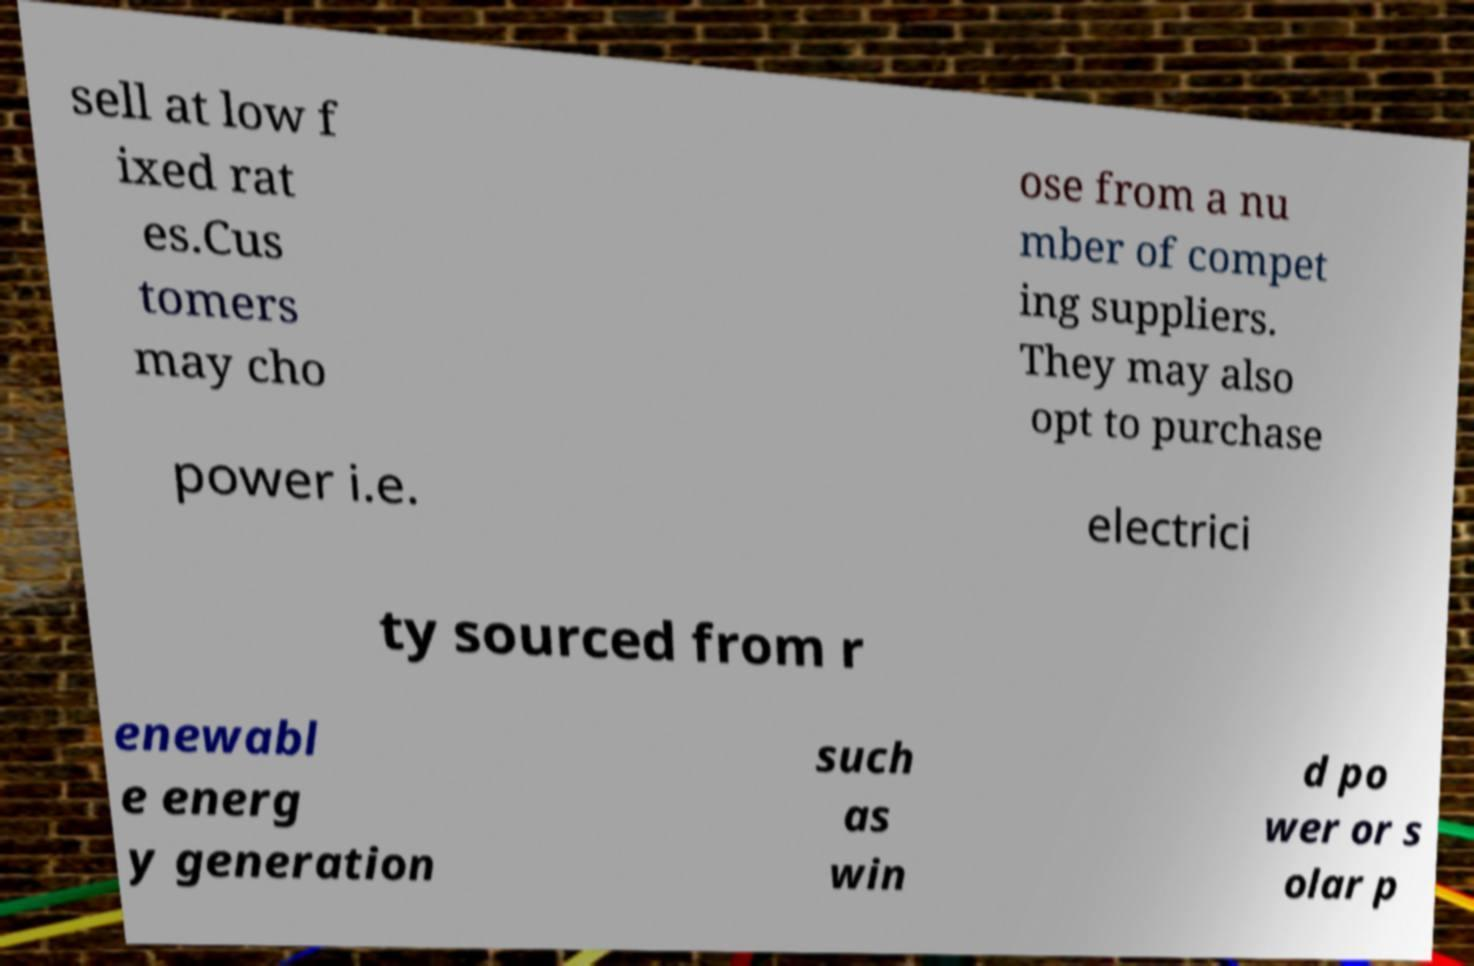Can you read and provide the text displayed in the image?This photo seems to have some interesting text. Can you extract and type it out for me? sell at low f ixed rat es.Cus tomers may cho ose from a nu mber of compet ing suppliers. They may also opt to purchase power i.e. electrici ty sourced from r enewabl e energ y generation such as win d po wer or s olar p 